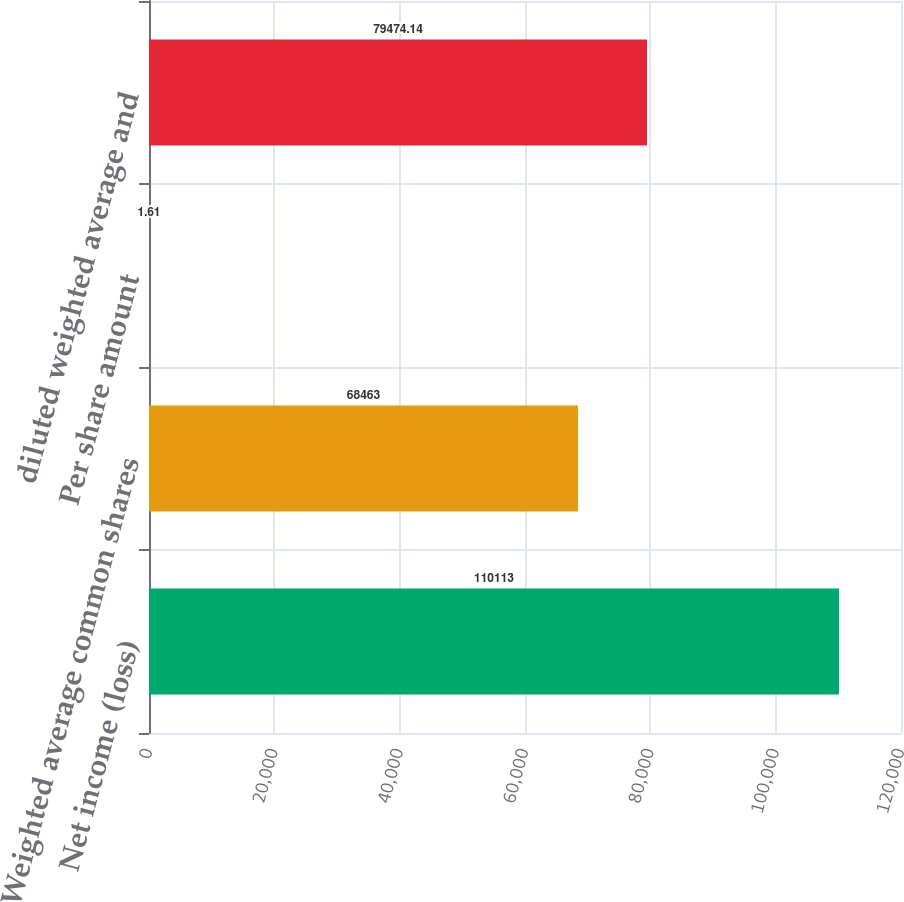Convert chart. <chart><loc_0><loc_0><loc_500><loc_500><bar_chart><fcel>Net income (loss)<fcel>Weighted average common shares<fcel>Per share amount<fcel>diluted weighted average and<nl><fcel>110113<fcel>68463<fcel>1.61<fcel>79474.1<nl></chart> 